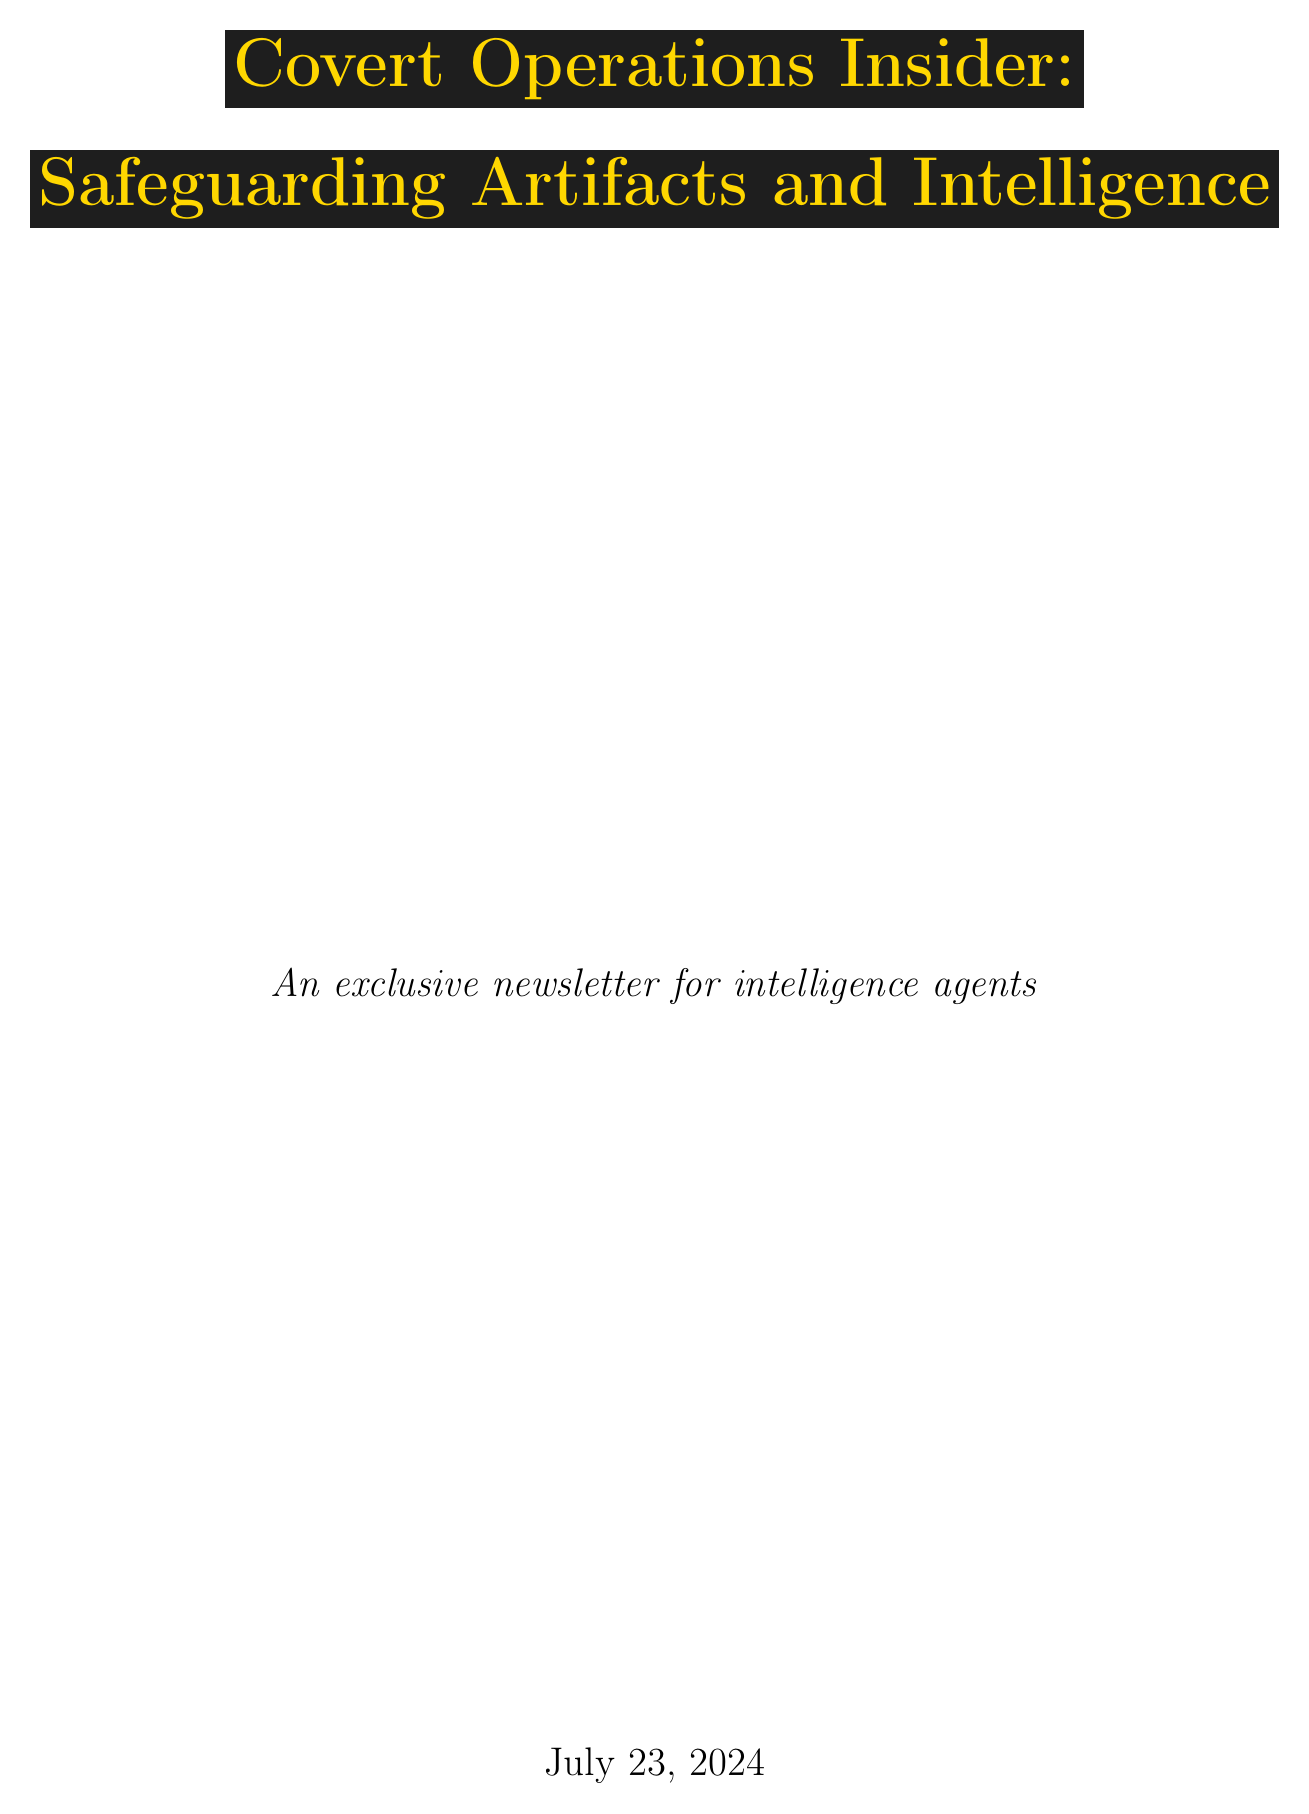what is the title of the newsletter? The title of the newsletter is mentioned at the beginning of the document, "Covert Operations Insider: Safeguarding Artifacts and Intelligence."
Answer: Covert Operations Insider: Safeguarding Artifacts and Intelligence who is the featured Mossad agent in the newsletter? The newsletter highlights Eli Cohen as a seasoned Mossad agent known for his expertise in artifact retrieval.
Answer: Eli Cohen what operation did Eli Cohen conduct in Syria? The document states that Eli Cohen successfully secured a 2,000-year-old Dead Sea Scroll fragment in Syria.
Answer: 2,000-year-old Dead Sea Scroll fragment which agency does Sarah Rodriguez work for? The profile indicates that Sarah Rodriguez is a CIA cyber intelligence specialist.
Answer: CIA what is one of the best practices shared by Sarah Rodriguez? The newsletter lists utilizing machine learning for pattern recognition in artifact trafficking as a best practice.
Answer: Utilizing machine learning for pattern recognition in artifact trafficking how long did the DGSE agent spend in an artifact smuggling ring? The document mentions that the DGSE agent spent three years embedded in the smuggling ring.
Answer: three years what type of techniques does James Ashworth recommend for museum staff? Ashworth recommends training museum staff in counter-surveillance techniques.
Answer: counter-surveillance techniques name one resource mentioned in the additional resources section. The additional resources section lists an "Artifact Authentication Field Guide."
Answer: Artifact Authentication Field Guide what is one operational highlight discussed by Maria Gonzalez from Interpol? Maria Gonzalez discusses leveraging international databases to track stolen artifacts as an operational highlight.
Answer: Leveraging international databases to track stolen artifacts 